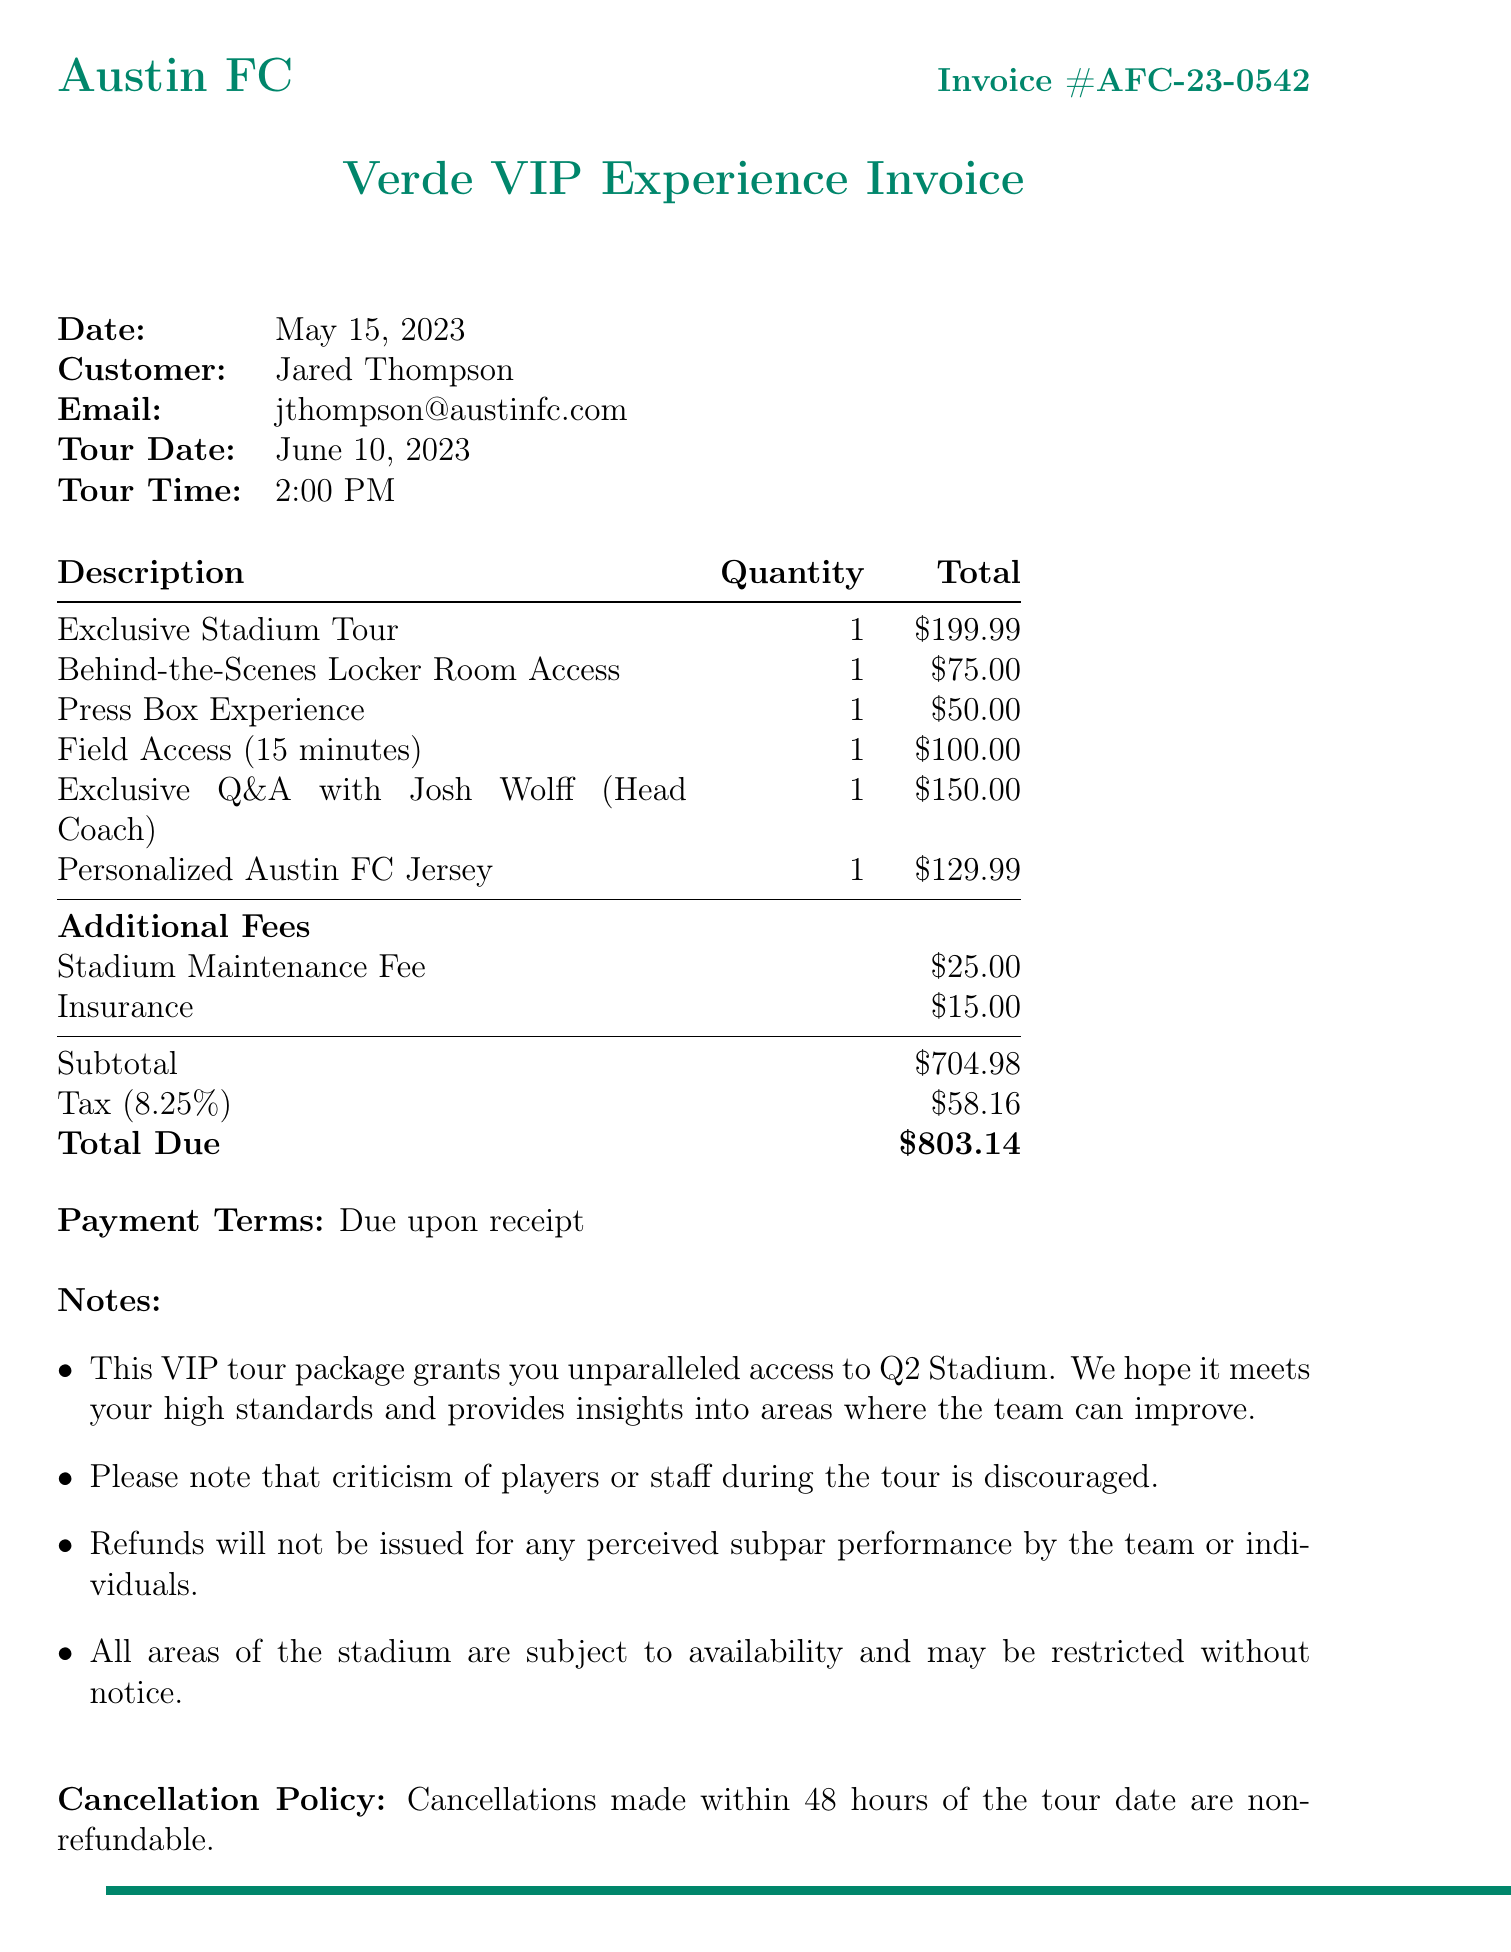what is the invoice number? The invoice number is prominently displayed in the document.
Answer: AFC-23-0542 who is the customer? The customer's name can be found in the customer section of the document.
Answer: Jared Thompson what is the tour date? The tour date is specified under "Tour Date" in the invoice.
Answer: June 10, 2023 how much is the subtotal? The subtotal is calculated before tax and additional fees are added, as shown in the document.
Answer: 704.98 what is the total due? The total due can be found clearly stated at the bottom of the invoice.
Answer: 803.14 what exclusive experience is available with the tour? The invoice lists various exclusive experiences available as part of the tour package.
Answer: Behind-the-Scenes Locker Room Access how much is the insurance fee? The insurance fee is detailed in the additional fees section of the document.
Answer: 15.00 what is the cancellation policy? The document specifies the terms for cancellation, which can be found near the end.
Answer: Cancellations made within 48 hours of the tour date are non-refundable what is the payment term? Payment terms are outlined in the invoice, indicating when payment is expected.
Answer: Due upon receipt 